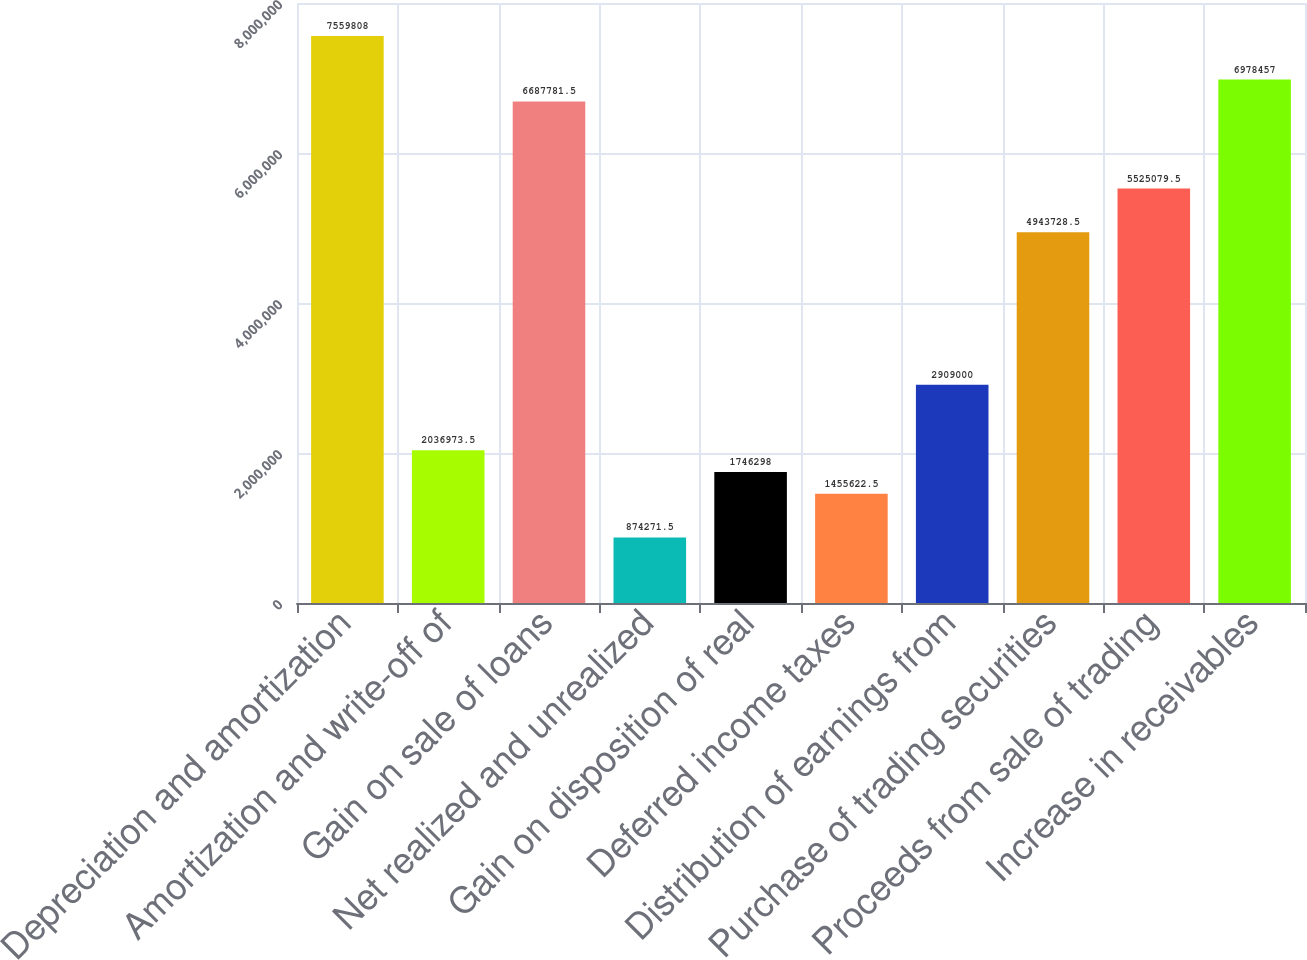Convert chart. <chart><loc_0><loc_0><loc_500><loc_500><bar_chart><fcel>Depreciation and amortization<fcel>Amortization and write-off of<fcel>Gain on sale of loans<fcel>Net realized and unrealized<fcel>Gain on disposition of real<fcel>Deferred income taxes<fcel>Distribution of earnings from<fcel>Purchase of trading securities<fcel>Proceeds from sale of trading<fcel>Increase in receivables<nl><fcel>7.55981e+06<fcel>2.03697e+06<fcel>6.68778e+06<fcel>874272<fcel>1.7463e+06<fcel>1.45562e+06<fcel>2.909e+06<fcel>4.94373e+06<fcel>5.52508e+06<fcel>6.97846e+06<nl></chart> 